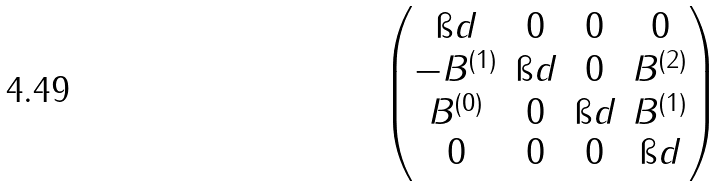Convert formula to latex. <formula><loc_0><loc_0><loc_500><loc_500>\begin{pmatrix} \i d & 0 & 0 & 0 \\ - B ^ { ( 1 ) } & \i d & 0 & B ^ { ( 2 ) } \\ B ^ { ( 0 ) } & 0 & \i d & B ^ { ( 1 ) } \\ 0 & 0 & 0 & \i d \end{pmatrix}</formula> 